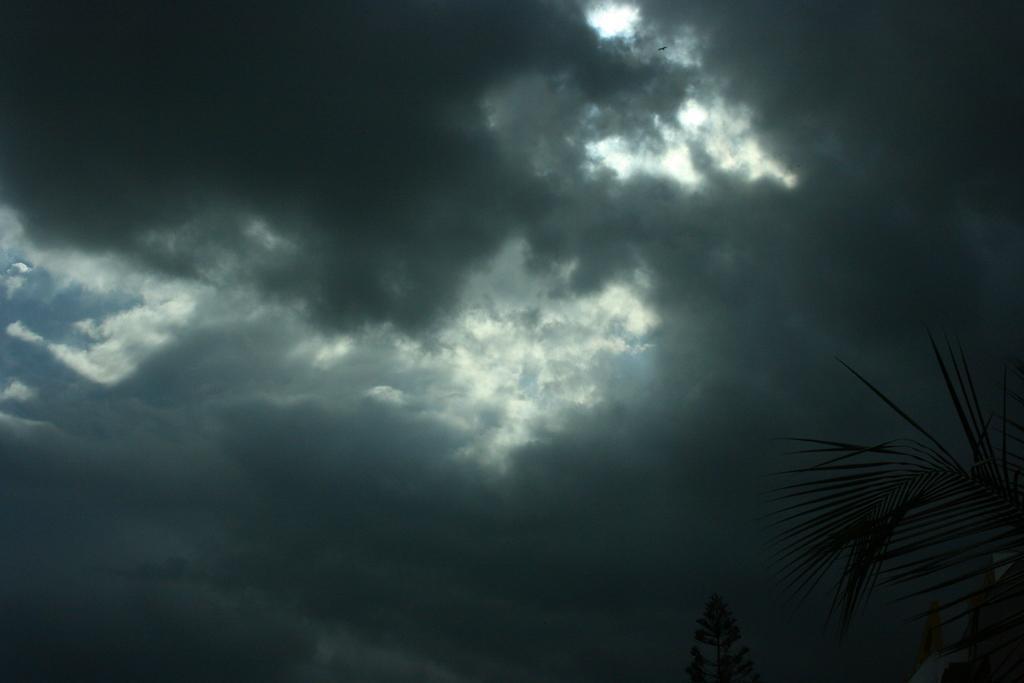Could you give a brief overview of what you see in this image? In this picture we can see trees and in the background we can see the sky with clouds. 